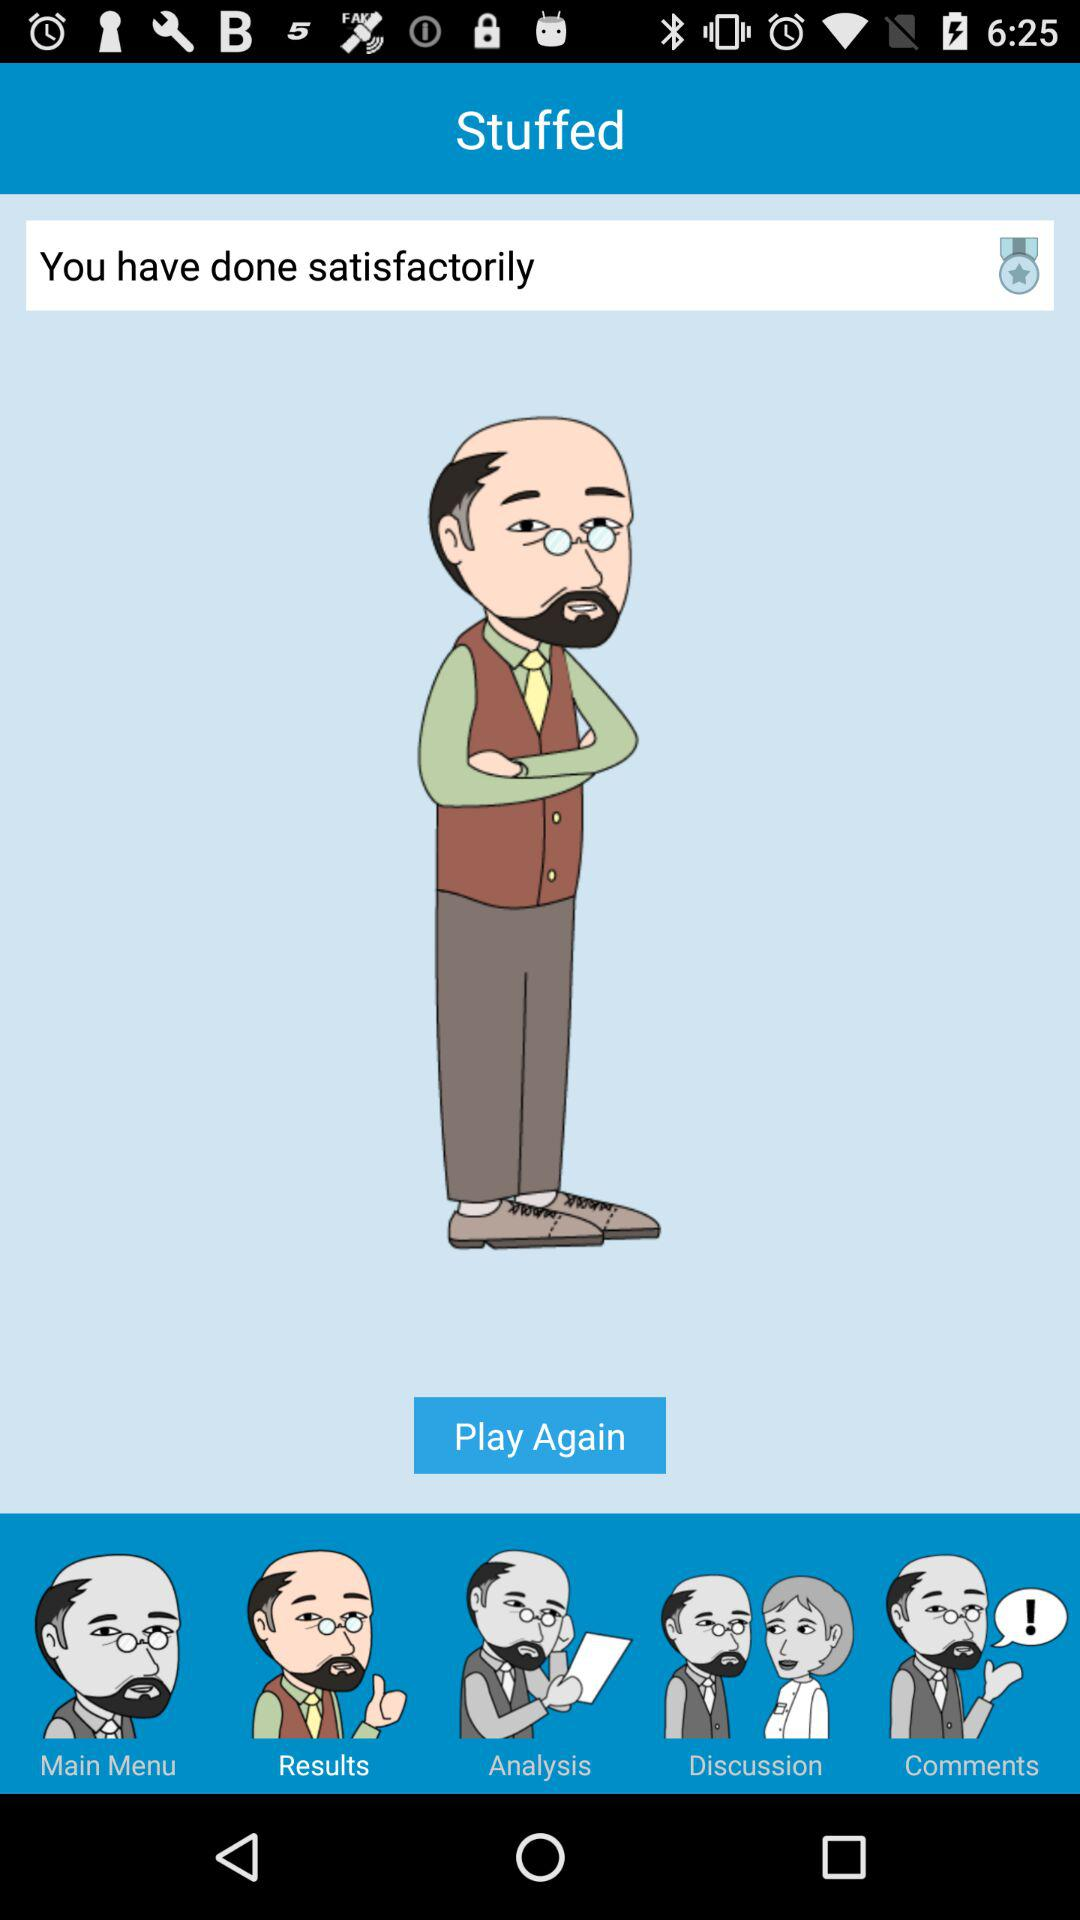Which tab is selected? The selected tab is "Results". 